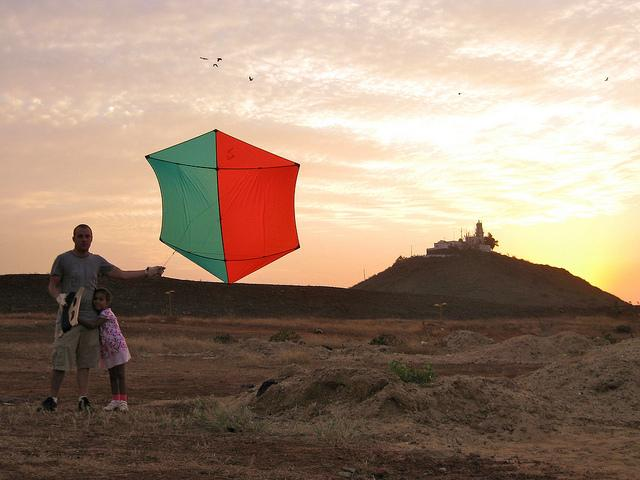What is on the item in the man's right hand?

Choices:
A) nothing
B) kite string
C) dog bone
D) memo kite string 